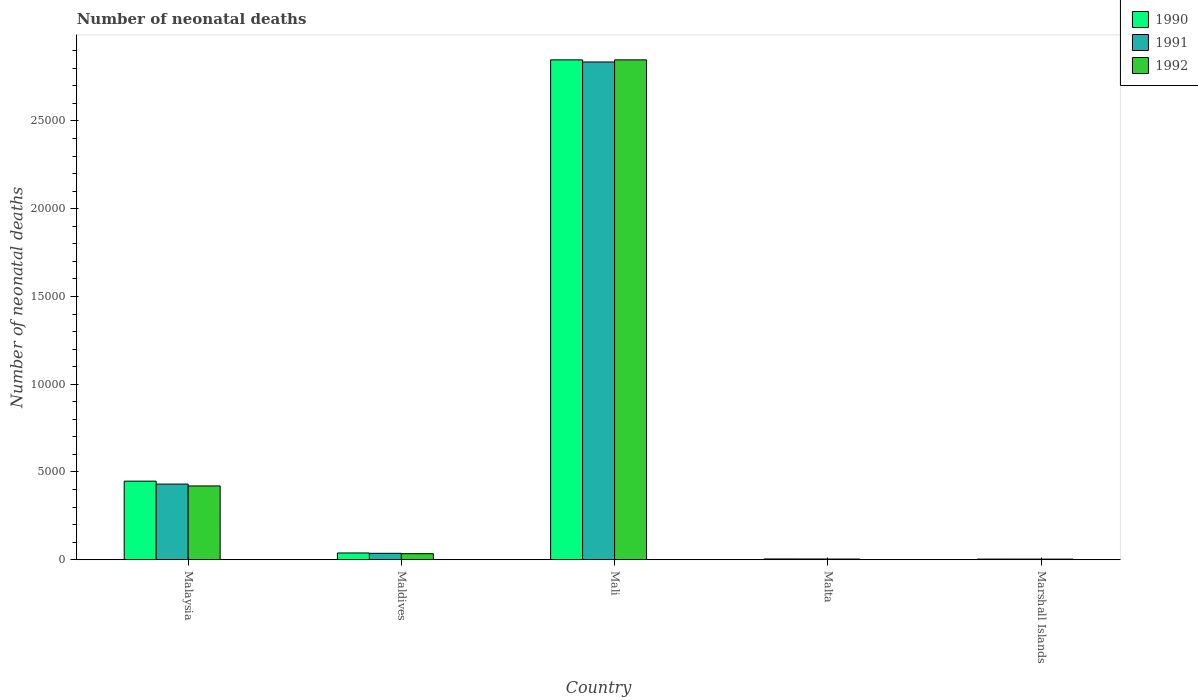How many different coloured bars are there?
Provide a succinct answer. 3. Are the number of bars per tick equal to the number of legend labels?
Keep it short and to the point. Yes. How many bars are there on the 5th tick from the left?
Give a very brief answer. 3. What is the label of the 3rd group of bars from the left?
Offer a very short reply. Mali. In how many cases, is the number of bars for a given country not equal to the number of legend labels?
Offer a terse response. 0. What is the number of neonatal deaths in in 1991 in Mali?
Your answer should be very brief. 2.84e+04. Across all countries, what is the maximum number of neonatal deaths in in 1991?
Provide a short and direct response. 2.84e+04. Across all countries, what is the minimum number of neonatal deaths in in 1992?
Offer a terse response. 38. In which country was the number of neonatal deaths in in 1990 maximum?
Keep it short and to the point. Mali. In which country was the number of neonatal deaths in in 1990 minimum?
Provide a short and direct response. Marshall Islands. What is the total number of neonatal deaths in in 1992 in the graph?
Make the answer very short. 3.31e+04. What is the difference between the number of neonatal deaths in in 1992 in Maldives and that in Marshall Islands?
Offer a terse response. 308. What is the difference between the number of neonatal deaths in in 1991 in Maldives and the number of neonatal deaths in in 1992 in Mali?
Make the answer very short. -2.81e+04. What is the average number of neonatal deaths in in 1991 per country?
Your answer should be very brief. 6624. What is the difference between the number of neonatal deaths in of/in 1990 and number of neonatal deaths in of/in 1991 in Mali?
Give a very brief answer. 120. In how many countries, is the number of neonatal deaths in in 1992 greater than 24000?
Offer a terse response. 1. What is the ratio of the number of neonatal deaths in in 1992 in Malaysia to that in Mali?
Your response must be concise. 0.15. Is the number of neonatal deaths in in 1991 in Malta less than that in Marshall Islands?
Make the answer very short. No. Is the difference between the number of neonatal deaths in in 1990 in Malta and Marshall Islands greater than the difference between the number of neonatal deaths in in 1991 in Malta and Marshall Islands?
Keep it short and to the point. Yes. What is the difference between the highest and the second highest number of neonatal deaths in in 1992?
Offer a very short reply. 3860. What is the difference between the highest and the lowest number of neonatal deaths in in 1992?
Ensure brevity in your answer.  2.84e+04. What does the 1st bar from the left in Mali represents?
Your answer should be compact. 1990. How many bars are there?
Provide a succinct answer. 15. Are all the bars in the graph horizontal?
Offer a very short reply. No. Does the graph contain any zero values?
Give a very brief answer. No. Does the graph contain grids?
Provide a succinct answer. No. Where does the legend appear in the graph?
Provide a succinct answer. Top right. How many legend labels are there?
Ensure brevity in your answer.  3. How are the legend labels stacked?
Your answer should be compact. Vertical. What is the title of the graph?
Provide a succinct answer. Number of neonatal deaths. Does "1997" appear as one of the legend labels in the graph?
Provide a succinct answer. No. What is the label or title of the X-axis?
Provide a succinct answer. Country. What is the label or title of the Y-axis?
Ensure brevity in your answer.  Number of neonatal deaths. What is the Number of neonatal deaths in 1990 in Malaysia?
Make the answer very short. 4479. What is the Number of neonatal deaths of 1991 in Malaysia?
Provide a succinct answer. 4311. What is the Number of neonatal deaths in 1992 in Malaysia?
Ensure brevity in your answer.  4206. What is the Number of neonatal deaths of 1990 in Maldives?
Provide a short and direct response. 387. What is the Number of neonatal deaths of 1991 in Maldives?
Provide a succinct answer. 367. What is the Number of neonatal deaths of 1992 in Maldives?
Keep it short and to the point. 346. What is the Number of neonatal deaths in 1990 in Mali?
Your answer should be compact. 2.85e+04. What is the Number of neonatal deaths of 1991 in Mali?
Ensure brevity in your answer.  2.84e+04. What is the Number of neonatal deaths of 1992 in Mali?
Provide a short and direct response. 2.85e+04. What is the Number of neonatal deaths in 1991 in Malta?
Offer a terse response. 45. What is the Number of neonatal deaths of 1990 in Marshall Islands?
Keep it short and to the point. 40. What is the Number of neonatal deaths of 1991 in Marshall Islands?
Your response must be concise. 39. What is the Number of neonatal deaths of 1992 in Marshall Islands?
Your answer should be very brief. 38. Across all countries, what is the maximum Number of neonatal deaths of 1990?
Provide a short and direct response. 2.85e+04. Across all countries, what is the maximum Number of neonatal deaths of 1991?
Your answer should be compact. 2.84e+04. Across all countries, what is the maximum Number of neonatal deaths in 1992?
Provide a succinct answer. 2.85e+04. Across all countries, what is the minimum Number of neonatal deaths of 1990?
Your answer should be very brief. 40. Across all countries, what is the minimum Number of neonatal deaths of 1991?
Offer a terse response. 39. Across all countries, what is the minimum Number of neonatal deaths of 1992?
Your answer should be very brief. 38. What is the total Number of neonatal deaths of 1990 in the graph?
Provide a short and direct response. 3.34e+04. What is the total Number of neonatal deaths in 1991 in the graph?
Keep it short and to the point. 3.31e+04. What is the total Number of neonatal deaths of 1992 in the graph?
Your answer should be very brief. 3.31e+04. What is the difference between the Number of neonatal deaths of 1990 in Malaysia and that in Maldives?
Ensure brevity in your answer.  4092. What is the difference between the Number of neonatal deaths of 1991 in Malaysia and that in Maldives?
Provide a short and direct response. 3944. What is the difference between the Number of neonatal deaths in 1992 in Malaysia and that in Maldives?
Make the answer very short. 3860. What is the difference between the Number of neonatal deaths in 1990 in Malaysia and that in Mali?
Provide a short and direct response. -2.40e+04. What is the difference between the Number of neonatal deaths of 1991 in Malaysia and that in Mali?
Provide a short and direct response. -2.40e+04. What is the difference between the Number of neonatal deaths in 1992 in Malaysia and that in Mali?
Provide a short and direct response. -2.43e+04. What is the difference between the Number of neonatal deaths of 1990 in Malaysia and that in Malta?
Keep it short and to the point. 4432. What is the difference between the Number of neonatal deaths of 1991 in Malaysia and that in Malta?
Your response must be concise. 4266. What is the difference between the Number of neonatal deaths of 1992 in Malaysia and that in Malta?
Give a very brief answer. 4164. What is the difference between the Number of neonatal deaths in 1990 in Malaysia and that in Marshall Islands?
Make the answer very short. 4439. What is the difference between the Number of neonatal deaths in 1991 in Malaysia and that in Marshall Islands?
Ensure brevity in your answer.  4272. What is the difference between the Number of neonatal deaths of 1992 in Malaysia and that in Marshall Islands?
Ensure brevity in your answer.  4168. What is the difference between the Number of neonatal deaths of 1990 in Maldives and that in Mali?
Make the answer very short. -2.81e+04. What is the difference between the Number of neonatal deaths in 1991 in Maldives and that in Mali?
Ensure brevity in your answer.  -2.80e+04. What is the difference between the Number of neonatal deaths in 1992 in Maldives and that in Mali?
Your response must be concise. -2.81e+04. What is the difference between the Number of neonatal deaths of 1990 in Maldives and that in Malta?
Provide a succinct answer. 340. What is the difference between the Number of neonatal deaths in 1991 in Maldives and that in Malta?
Your response must be concise. 322. What is the difference between the Number of neonatal deaths in 1992 in Maldives and that in Malta?
Provide a succinct answer. 304. What is the difference between the Number of neonatal deaths in 1990 in Maldives and that in Marshall Islands?
Your response must be concise. 347. What is the difference between the Number of neonatal deaths of 1991 in Maldives and that in Marshall Islands?
Provide a short and direct response. 328. What is the difference between the Number of neonatal deaths of 1992 in Maldives and that in Marshall Islands?
Your response must be concise. 308. What is the difference between the Number of neonatal deaths in 1990 in Mali and that in Malta?
Make the answer very short. 2.84e+04. What is the difference between the Number of neonatal deaths of 1991 in Mali and that in Malta?
Ensure brevity in your answer.  2.83e+04. What is the difference between the Number of neonatal deaths of 1992 in Mali and that in Malta?
Your response must be concise. 2.84e+04. What is the difference between the Number of neonatal deaths of 1990 in Mali and that in Marshall Islands?
Your answer should be very brief. 2.84e+04. What is the difference between the Number of neonatal deaths of 1991 in Mali and that in Marshall Islands?
Your answer should be compact. 2.83e+04. What is the difference between the Number of neonatal deaths of 1992 in Mali and that in Marshall Islands?
Ensure brevity in your answer.  2.84e+04. What is the difference between the Number of neonatal deaths of 1990 in Malta and that in Marshall Islands?
Your answer should be very brief. 7. What is the difference between the Number of neonatal deaths in 1992 in Malta and that in Marshall Islands?
Offer a terse response. 4. What is the difference between the Number of neonatal deaths in 1990 in Malaysia and the Number of neonatal deaths in 1991 in Maldives?
Your answer should be compact. 4112. What is the difference between the Number of neonatal deaths in 1990 in Malaysia and the Number of neonatal deaths in 1992 in Maldives?
Your answer should be compact. 4133. What is the difference between the Number of neonatal deaths in 1991 in Malaysia and the Number of neonatal deaths in 1992 in Maldives?
Your response must be concise. 3965. What is the difference between the Number of neonatal deaths in 1990 in Malaysia and the Number of neonatal deaths in 1991 in Mali?
Offer a very short reply. -2.39e+04. What is the difference between the Number of neonatal deaths in 1990 in Malaysia and the Number of neonatal deaths in 1992 in Mali?
Your answer should be compact. -2.40e+04. What is the difference between the Number of neonatal deaths in 1991 in Malaysia and the Number of neonatal deaths in 1992 in Mali?
Your answer should be very brief. -2.42e+04. What is the difference between the Number of neonatal deaths in 1990 in Malaysia and the Number of neonatal deaths in 1991 in Malta?
Keep it short and to the point. 4434. What is the difference between the Number of neonatal deaths in 1990 in Malaysia and the Number of neonatal deaths in 1992 in Malta?
Offer a very short reply. 4437. What is the difference between the Number of neonatal deaths in 1991 in Malaysia and the Number of neonatal deaths in 1992 in Malta?
Provide a short and direct response. 4269. What is the difference between the Number of neonatal deaths in 1990 in Malaysia and the Number of neonatal deaths in 1991 in Marshall Islands?
Offer a very short reply. 4440. What is the difference between the Number of neonatal deaths in 1990 in Malaysia and the Number of neonatal deaths in 1992 in Marshall Islands?
Ensure brevity in your answer.  4441. What is the difference between the Number of neonatal deaths of 1991 in Malaysia and the Number of neonatal deaths of 1992 in Marshall Islands?
Offer a very short reply. 4273. What is the difference between the Number of neonatal deaths in 1990 in Maldives and the Number of neonatal deaths in 1991 in Mali?
Give a very brief answer. -2.80e+04. What is the difference between the Number of neonatal deaths of 1990 in Maldives and the Number of neonatal deaths of 1992 in Mali?
Your response must be concise. -2.81e+04. What is the difference between the Number of neonatal deaths in 1991 in Maldives and the Number of neonatal deaths in 1992 in Mali?
Your answer should be compact. -2.81e+04. What is the difference between the Number of neonatal deaths in 1990 in Maldives and the Number of neonatal deaths in 1991 in Malta?
Ensure brevity in your answer.  342. What is the difference between the Number of neonatal deaths in 1990 in Maldives and the Number of neonatal deaths in 1992 in Malta?
Ensure brevity in your answer.  345. What is the difference between the Number of neonatal deaths of 1991 in Maldives and the Number of neonatal deaths of 1992 in Malta?
Make the answer very short. 325. What is the difference between the Number of neonatal deaths in 1990 in Maldives and the Number of neonatal deaths in 1991 in Marshall Islands?
Ensure brevity in your answer.  348. What is the difference between the Number of neonatal deaths in 1990 in Maldives and the Number of neonatal deaths in 1992 in Marshall Islands?
Offer a terse response. 349. What is the difference between the Number of neonatal deaths of 1991 in Maldives and the Number of neonatal deaths of 1992 in Marshall Islands?
Offer a very short reply. 329. What is the difference between the Number of neonatal deaths in 1990 in Mali and the Number of neonatal deaths in 1991 in Malta?
Provide a succinct answer. 2.84e+04. What is the difference between the Number of neonatal deaths in 1990 in Mali and the Number of neonatal deaths in 1992 in Malta?
Give a very brief answer. 2.84e+04. What is the difference between the Number of neonatal deaths in 1991 in Mali and the Number of neonatal deaths in 1992 in Malta?
Provide a short and direct response. 2.83e+04. What is the difference between the Number of neonatal deaths in 1990 in Mali and the Number of neonatal deaths in 1991 in Marshall Islands?
Ensure brevity in your answer.  2.84e+04. What is the difference between the Number of neonatal deaths of 1990 in Mali and the Number of neonatal deaths of 1992 in Marshall Islands?
Your answer should be very brief. 2.84e+04. What is the difference between the Number of neonatal deaths of 1991 in Mali and the Number of neonatal deaths of 1992 in Marshall Islands?
Give a very brief answer. 2.83e+04. What is the difference between the Number of neonatal deaths in 1990 in Malta and the Number of neonatal deaths in 1992 in Marshall Islands?
Offer a terse response. 9. What is the difference between the Number of neonatal deaths in 1991 in Malta and the Number of neonatal deaths in 1992 in Marshall Islands?
Ensure brevity in your answer.  7. What is the average Number of neonatal deaths of 1990 per country?
Provide a succinct answer. 6686.2. What is the average Number of neonatal deaths in 1991 per country?
Offer a very short reply. 6624. What is the average Number of neonatal deaths in 1992 per country?
Your response must be concise. 6622. What is the difference between the Number of neonatal deaths of 1990 and Number of neonatal deaths of 1991 in Malaysia?
Ensure brevity in your answer.  168. What is the difference between the Number of neonatal deaths of 1990 and Number of neonatal deaths of 1992 in Malaysia?
Make the answer very short. 273. What is the difference between the Number of neonatal deaths of 1991 and Number of neonatal deaths of 1992 in Malaysia?
Offer a very short reply. 105. What is the difference between the Number of neonatal deaths of 1990 and Number of neonatal deaths of 1991 in Maldives?
Your answer should be very brief. 20. What is the difference between the Number of neonatal deaths in 1990 and Number of neonatal deaths in 1991 in Mali?
Give a very brief answer. 120. What is the difference between the Number of neonatal deaths in 1990 and Number of neonatal deaths in 1992 in Mali?
Make the answer very short. 0. What is the difference between the Number of neonatal deaths of 1991 and Number of neonatal deaths of 1992 in Mali?
Offer a terse response. -120. What is the difference between the Number of neonatal deaths in 1990 and Number of neonatal deaths in 1991 in Malta?
Provide a succinct answer. 2. What is the difference between the Number of neonatal deaths of 1990 and Number of neonatal deaths of 1992 in Malta?
Provide a succinct answer. 5. What is the difference between the Number of neonatal deaths in 1991 and Number of neonatal deaths in 1992 in Malta?
Your response must be concise. 3. What is the difference between the Number of neonatal deaths in 1990 and Number of neonatal deaths in 1992 in Marshall Islands?
Keep it short and to the point. 2. What is the ratio of the Number of neonatal deaths of 1990 in Malaysia to that in Maldives?
Ensure brevity in your answer.  11.57. What is the ratio of the Number of neonatal deaths in 1991 in Malaysia to that in Maldives?
Provide a short and direct response. 11.75. What is the ratio of the Number of neonatal deaths of 1992 in Malaysia to that in Maldives?
Provide a short and direct response. 12.16. What is the ratio of the Number of neonatal deaths in 1990 in Malaysia to that in Mali?
Your response must be concise. 0.16. What is the ratio of the Number of neonatal deaths of 1991 in Malaysia to that in Mali?
Provide a succinct answer. 0.15. What is the ratio of the Number of neonatal deaths in 1992 in Malaysia to that in Mali?
Ensure brevity in your answer.  0.15. What is the ratio of the Number of neonatal deaths in 1990 in Malaysia to that in Malta?
Offer a very short reply. 95.3. What is the ratio of the Number of neonatal deaths of 1991 in Malaysia to that in Malta?
Your answer should be very brief. 95.8. What is the ratio of the Number of neonatal deaths of 1992 in Malaysia to that in Malta?
Provide a succinct answer. 100.14. What is the ratio of the Number of neonatal deaths in 1990 in Malaysia to that in Marshall Islands?
Offer a terse response. 111.97. What is the ratio of the Number of neonatal deaths in 1991 in Malaysia to that in Marshall Islands?
Ensure brevity in your answer.  110.54. What is the ratio of the Number of neonatal deaths in 1992 in Malaysia to that in Marshall Islands?
Your answer should be compact. 110.68. What is the ratio of the Number of neonatal deaths in 1990 in Maldives to that in Mali?
Provide a succinct answer. 0.01. What is the ratio of the Number of neonatal deaths of 1991 in Maldives to that in Mali?
Offer a very short reply. 0.01. What is the ratio of the Number of neonatal deaths of 1992 in Maldives to that in Mali?
Give a very brief answer. 0.01. What is the ratio of the Number of neonatal deaths in 1990 in Maldives to that in Malta?
Your response must be concise. 8.23. What is the ratio of the Number of neonatal deaths in 1991 in Maldives to that in Malta?
Your answer should be very brief. 8.16. What is the ratio of the Number of neonatal deaths in 1992 in Maldives to that in Malta?
Your answer should be very brief. 8.24. What is the ratio of the Number of neonatal deaths of 1990 in Maldives to that in Marshall Islands?
Offer a terse response. 9.68. What is the ratio of the Number of neonatal deaths of 1991 in Maldives to that in Marshall Islands?
Keep it short and to the point. 9.41. What is the ratio of the Number of neonatal deaths in 1992 in Maldives to that in Marshall Islands?
Make the answer very short. 9.11. What is the ratio of the Number of neonatal deaths in 1990 in Mali to that in Malta?
Keep it short and to the point. 605.91. What is the ratio of the Number of neonatal deaths in 1991 in Mali to that in Malta?
Provide a short and direct response. 630.18. What is the ratio of the Number of neonatal deaths in 1992 in Mali to that in Malta?
Ensure brevity in your answer.  678.05. What is the ratio of the Number of neonatal deaths in 1990 in Mali to that in Marshall Islands?
Your answer should be compact. 711.95. What is the ratio of the Number of neonatal deaths of 1991 in Mali to that in Marshall Islands?
Offer a very short reply. 727.13. What is the ratio of the Number of neonatal deaths of 1992 in Mali to that in Marshall Islands?
Give a very brief answer. 749.42. What is the ratio of the Number of neonatal deaths of 1990 in Malta to that in Marshall Islands?
Your answer should be very brief. 1.18. What is the ratio of the Number of neonatal deaths in 1991 in Malta to that in Marshall Islands?
Make the answer very short. 1.15. What is the ratio of the Number of neonatal deaths in 1992 in Malta to that in Marshall Islands?
Ensure brevity in your answer.  1.11. What is the difference between the highest and the second highest Number of neonatal deaths in 1990?
Your response must be concise. 2.40e+04. What is the difference between the highest and the second highest Number of neonatal deaths of 1991?
Make the answer very short. 2.40e+04. What is the difference between the highest and the second highest Number of neonatal deaths in 1992?
Your answer should be compact. 2.43e+04. What is the difference between the highest and the lowest Number of neonatal deaths of 1990?
Your answer should be very brief. 2.84e+04. What is the difference between the highest and the lowest Number of neonatal deaths of 1991?
Your response must be concise. 2.83e+04. What is the difference between the highest and the lowest Number of neonatal deaths in 1992?
Offer a terse response. 2.84e+04. 